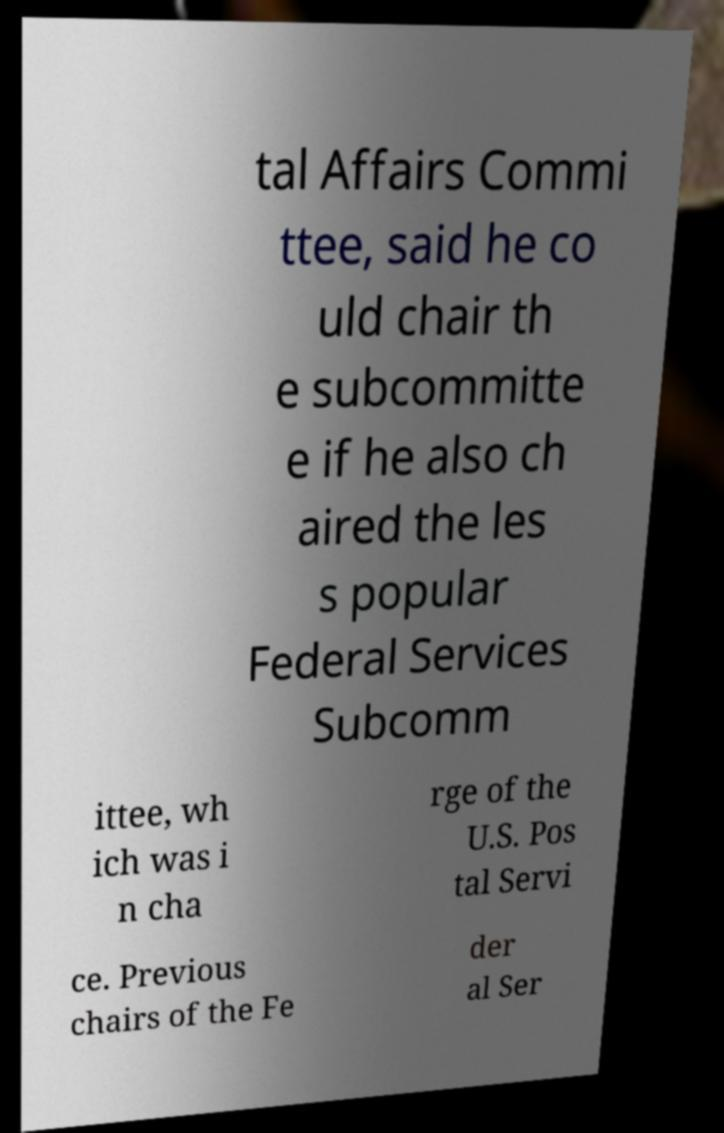For documentation purposes, I need the text within this image transcribed. Could you provide that? tal Affairs Commi ttee, said he co uld chair th e subcommitte e if he also ch aired the les s popular Federal Services Subcomm ittee, wh ich was i n cha rge of the U.S. Pos tal Servi ce. Previous chairs of the Fe der al Ser 